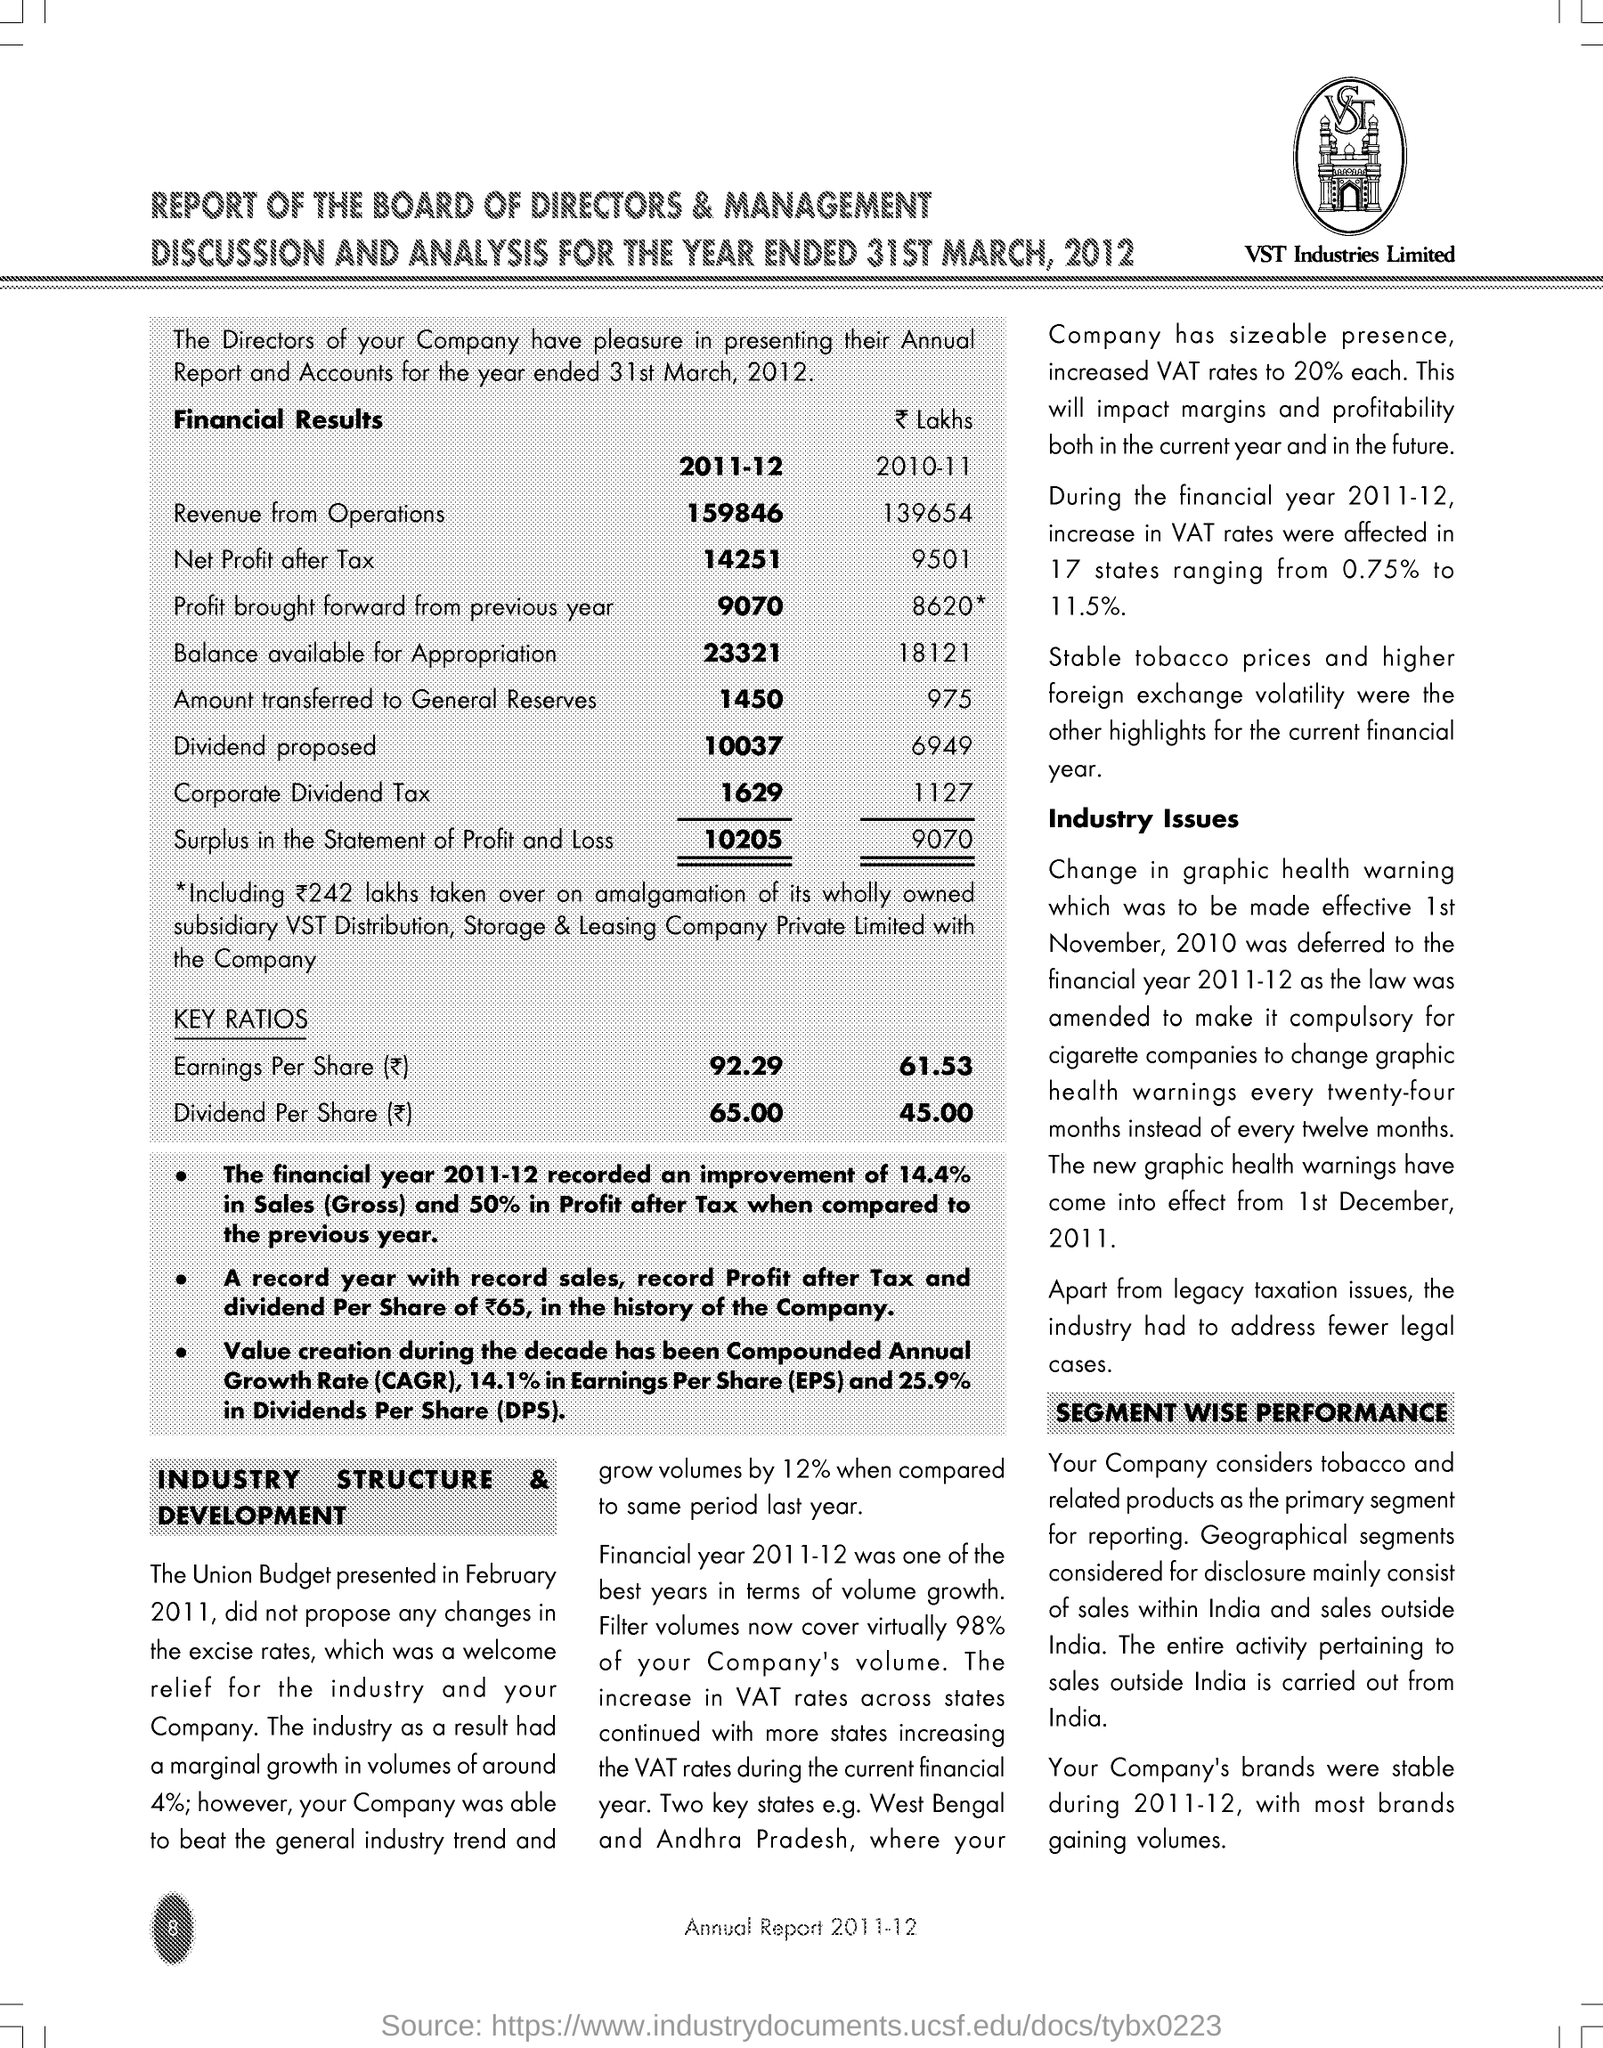What is the amount transferred to general reserves in the 2011-12?
Give a very brief answer. 1450. What is the earnings per share in rupees for the year of  2010-11?
Offer a very short reply. 61.53. What does eps stands for?
Your answer should be very brief. Earnings per share. What does cagr stands for
Offer a very short reply. Compounded Annual Growth Rate. 